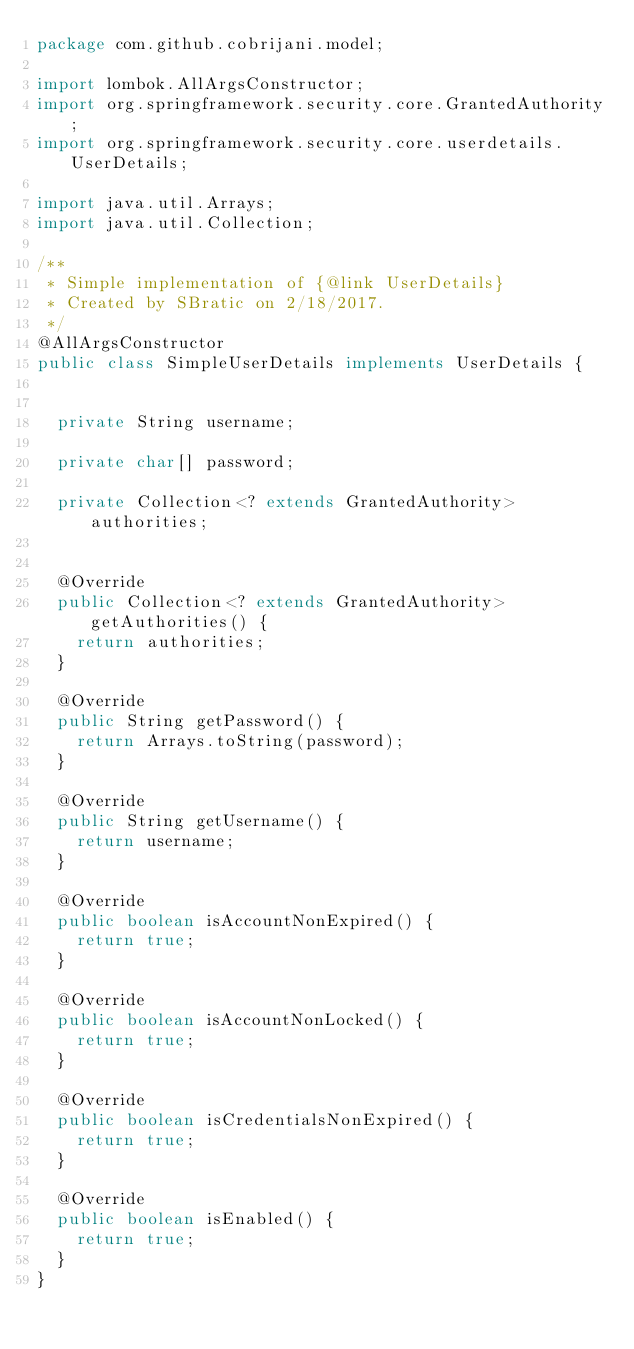Convert code to text. <code><loc_0><loc_0><loc_500><loc_500><_Java_>package com.github.cobrijani.model;

import lombok.AllArgsConstructor;
import org.springframework.security.core.GrantedAuthority;
import org.springframework.security.core.userdetails.UserDetails;

import java.util.Arrays;
import java.util.Collection;

/**
 * Simple implementation of {@link UserDetails}
 * Created by SBratic on 2/18/2017.
 */
@AllArgsConstructor
public class SimpleUserDetails implements UserDetails {


  private String username;

  private char[] password;

  private Collection<? extends GrantedAuthority> authorities;


  @Override
  public Collection<? extends GrantedAuthority> getAuthorities() {
    return authorities;
  }

  @Override
  public String getPassword() {
    return Arrays.toString(password);
  }

  @Override
  public String getUsername() {
    return username;
  }

  @Override
  public boolean isAccountNonExpired() {
    return true;
  }

  @Override
  public boolean isAccountNonLocked() {
    return true;
  }

  @Override
  public boolean isCredentialsNonExpired() {
    return true;
  }

  @Override
  public boolean isEnabled() {
    return true;
  }
}
</code> 